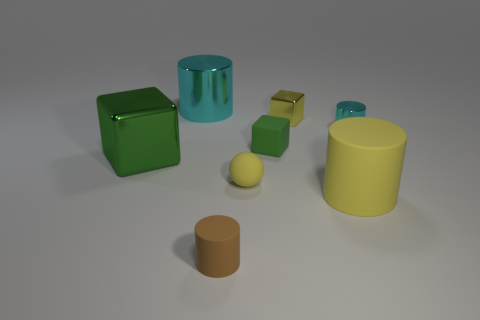Add 1 big cylinders. How many objects exist? 9 Subtract all blue cubes. Subtract all blue balls. How many cubes are left? 3 Subtract all balls. How many objects are left? 7 Add 7 tiny brown things. How many tiny brown things exist? 8 Subtract 0 gray balls. How many objects are left? 8 Subtract all tiny green things. Subtract all matte cylinders. How many objects are left? 5 Add 5 shiny cylinders. How many shiny cylinders are left? 7 